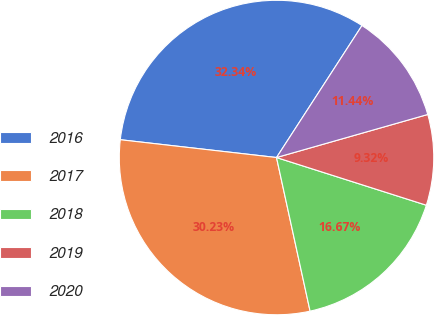Convert chart to OTSL. <chart><loc_0><loc_0><loc_500><loc_500><pie_chart><fcel>2016<fcel>2017<fcel>2018<fcel>2019<fcel>2020<nl><fcel>32.34%<fcel>30.23%<fcel>16.67%<fcel>9.32%<fcel>11.44%<nl></chart> 